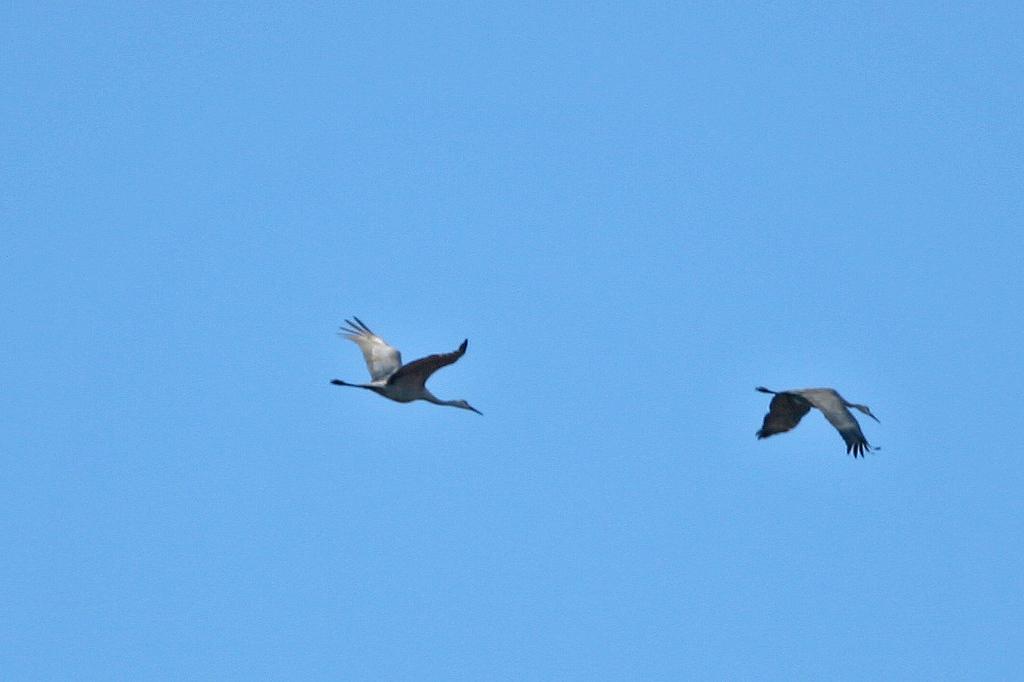Please provide a concise description of this image. In the image there are two birds flying in the sky. 